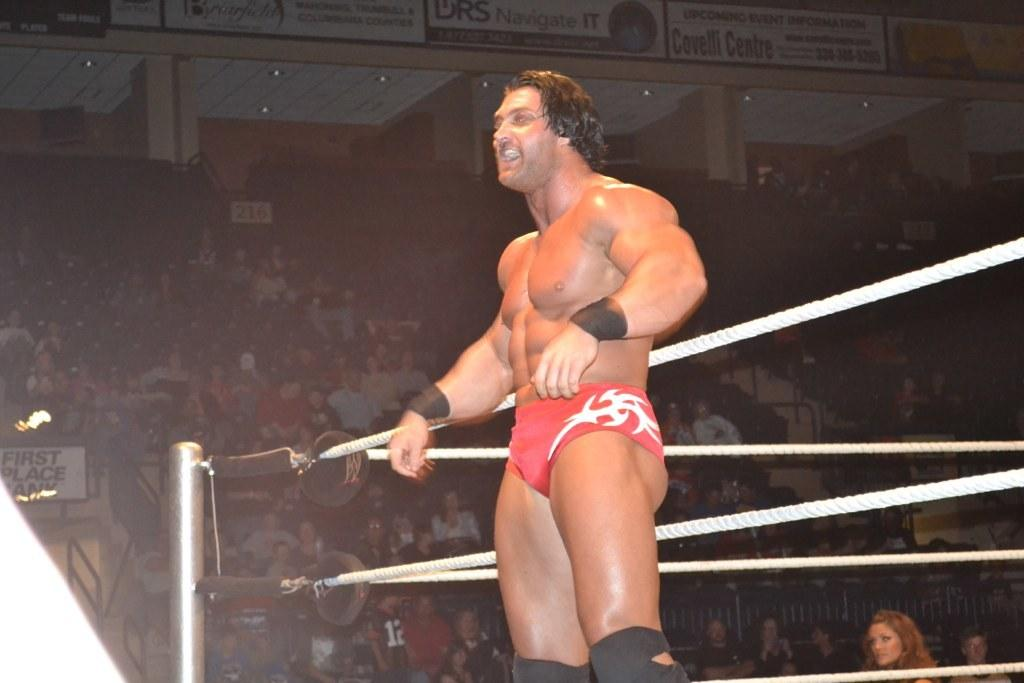<image>
Present a compact description of the photo's key features. a wrestler in the covelli Centre wearing red underpants 